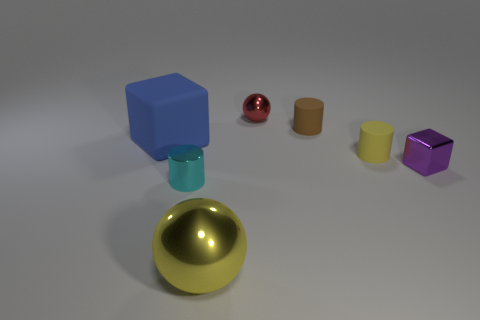There is a cyan object that is the same shape as the small yellow rubber thing; what material is it?
Give a very brief answer. Metal. What is the big yellow object made of?
Offer a very short reply. Metal. There is a object right of the yellow object to the right of the large metallic thing; what is its color?
Provide a short and direct response. Purple. Are there any big blue matte things that are behind the ball that is on the right side of the thing that is in front of the tiny metal cylinder?
Offer a terse response. No. The sphere that is made of the same material as the red thing is what color?
Give a very brief answer. Yellow. What number of things have the same material as the big cube?
Ensure brevity in your answer.  2. Is the material of the yellow sphere the same as the tiny cylinder that is behind the big rubber block?
Keep it short and to the point. No. What number of objects are shiny spheres that are behind the large metal ball or tiny rubber cylinders?
Ensure brevity in your answer.  3. How big is the cylinder on the left side of the ball that is on the right side of the yellow object that is in front of the cyan metal object?
Give a very brief answer. Small. There is a cylinder that is the same color as the large shiny ball; what is its material?
Your answer should be compact. Rubber. 